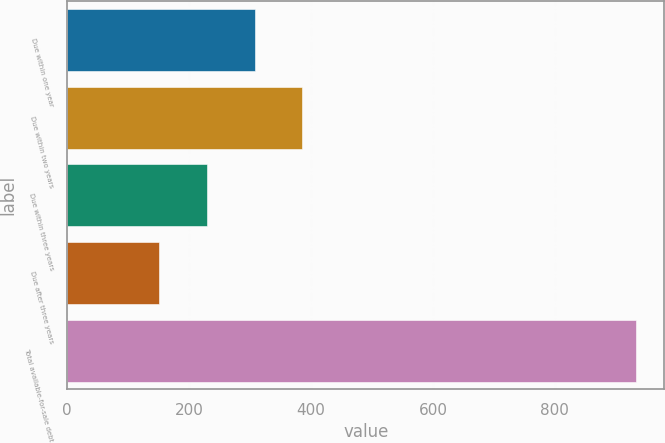Convert chart to OTSL. <chart><loc_0><loc_0><loc_500><loc_500><bar_chart><fcel>Due within one year<fcel>Due within two years<fcel>Due within three years<fcel>Due after three years<fcel>Total available-for-sale debt<nl><fcel>307.4<fcel>385.6<fcel>229.2<fcel>151<fcel>933<nl></chart> 